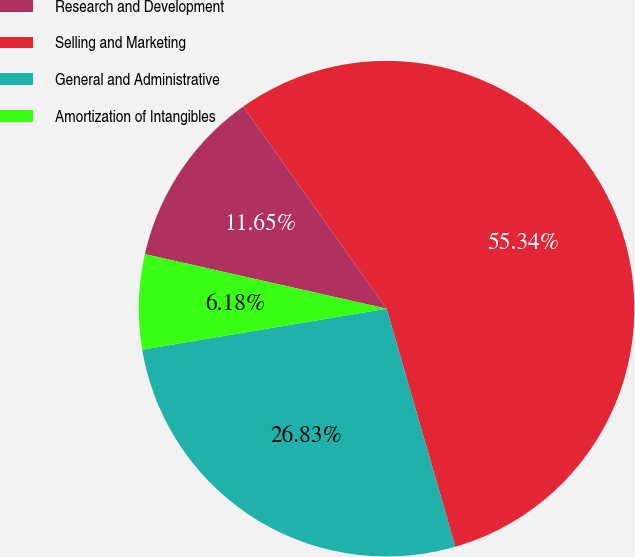Convert chart. <chart><loc_0><loc_0><loc_500><loc_500><pie_chart><fcel>Research and Development<fcel>Selling and Marketing<fcel>General and Administrative<fcel>Amortization of Intangibles<nl><fcel>11.65%<fcel>55.35%<fcel>26.83%<fcel>6.18%<nl></chart> 